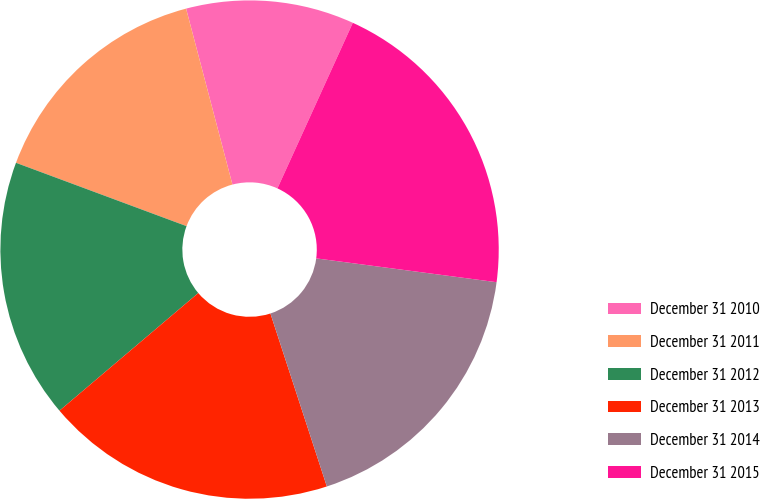Convert chart to OTSL. <chart><loc_0><loc_0><loc_500><loc_500><pie_chart><fcel>December 31 2010<fcel>December 31 2011<fcel>December 31 2012<fcel>December 31 2013<fcel>December 31 2014<fcel>December 31 2015<nl><fcel>10.9%<fcel>15.24%<fcel>16.85%<fcel>18.83%<fcel>17.89%<fcel>20.29%<nl></chart> 